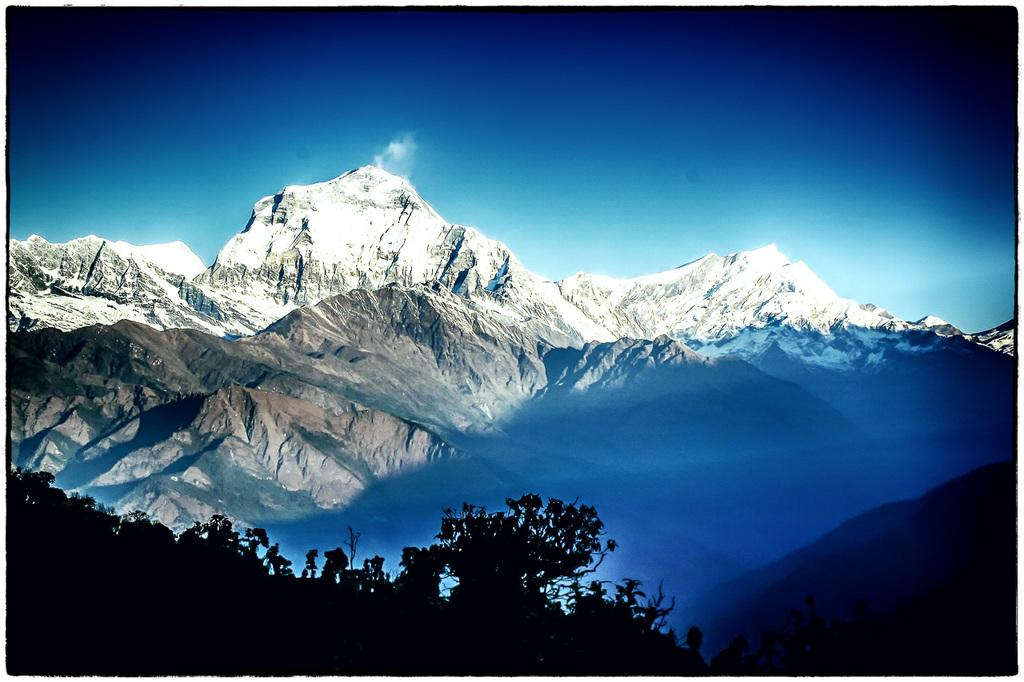What type of natural environment is depicted in the image? The image features many trees and mountains in the background. What color is the sky in the image? The sky is blue in the background of the image. Can you see the stranger's elbow in the image? There is no stranger present in the image, so it is not possible to see their elbow. 